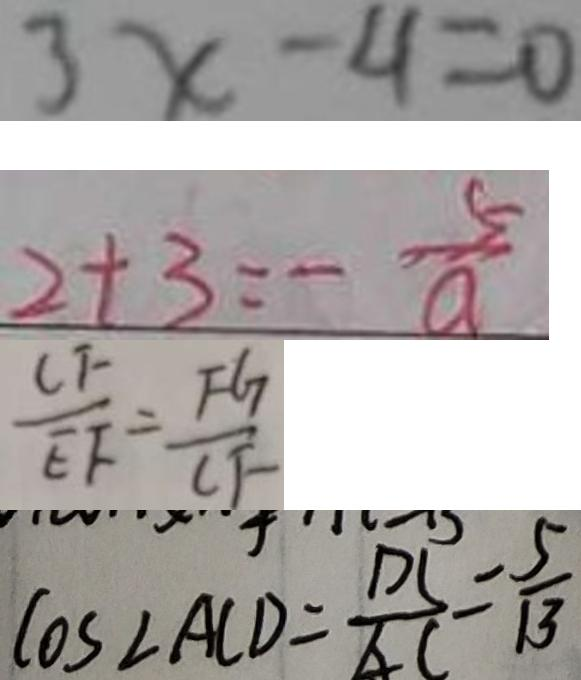<formula> <loc_0><loc_0><loc_500><loc_500>3 x - 4 = 0 
 2 + 3 = - \frac { 5 } { a } 
 \frac { C F } { E F } = \frac { F G } { C F } 
 \cos \angle A C D = \frac { D C } { A C } = \frac { 5 } { 1 3 }</formula> 